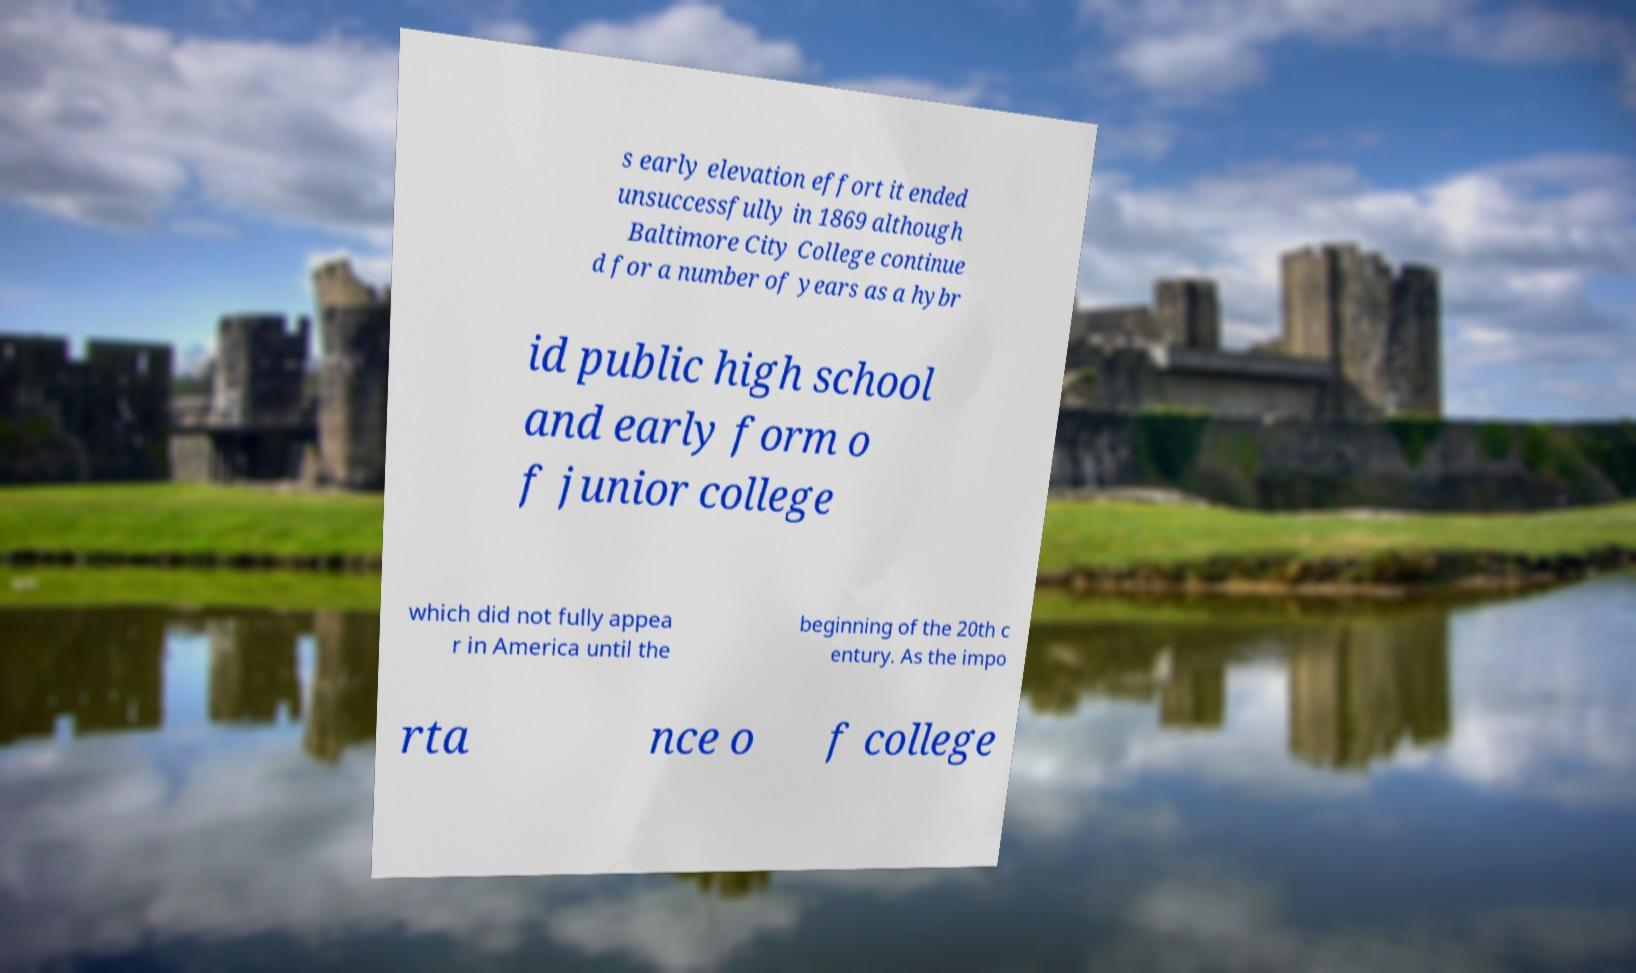Please identify and transcribe the text found in this image. s early elevation effort it ended unsuccessfully in 1869 although Baltimore City College continue d for a number of years as a hybr id public high school and early form o f junior college which did not fully appea r in America until the beginning of the 20th c entury. As the impo rta nce o f college 